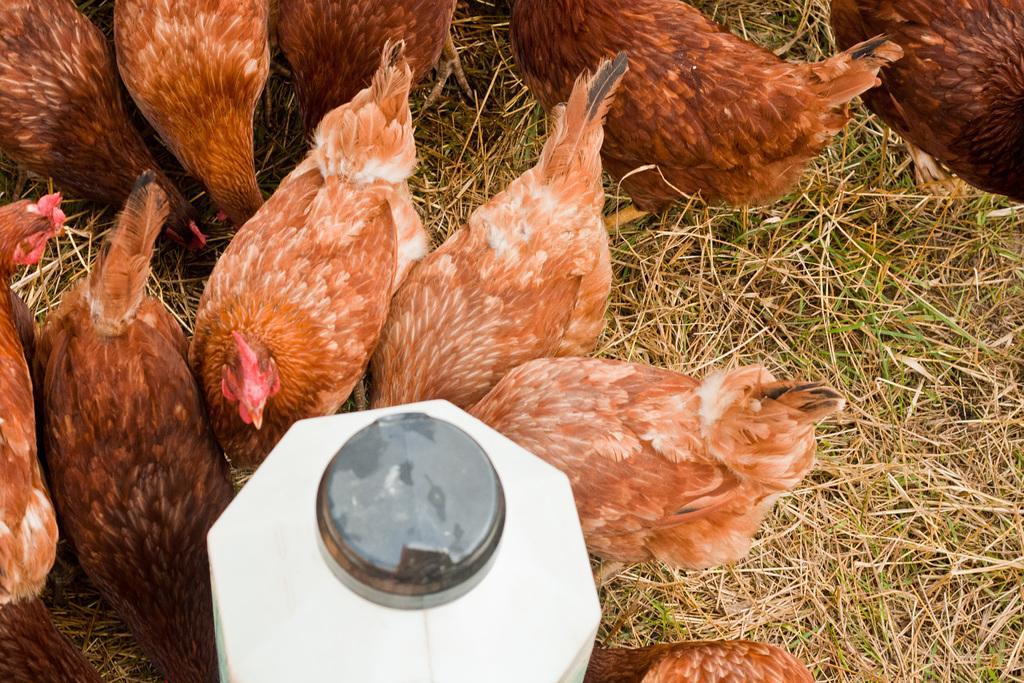Could you give a brief overview of what you see in this image? On the left side, there is a white color tin. Beside this town, there are hens on the grass on the ground. In the background, there are hens on the grass on the ground. 